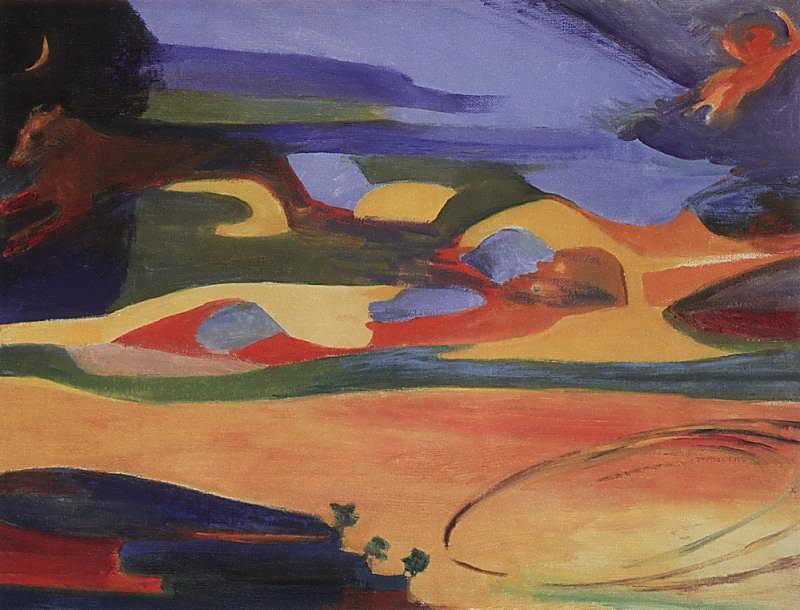What do you think is going on in this snapshot? This image is a vibrant display of abstract expressionism, filled with a medley of bold colors. The canvas predominantly features red, blue, and orange hues, accented by greens and yellows. The artist employs loose brushstrokes and color blending, giving the painting an expressive quality. It suggests a landscape with elements that hint at hills, trees, and a body of water. Despite its abstract nature, the painting evokes a distinct sense of place and atmosphere, showcasing the artist's skill in conveying emotion through color and form. 